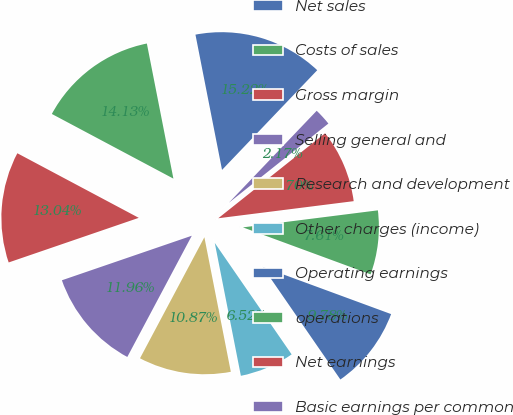Convert chart to OTSL. <chart><loc_0><loc_0><loc_500><loc_500><pie_chart><fcel>Net sales<fcel>Costs of sales<fcel>Gross margin<fcel>Selling general and<fcel>Research and development<fcel>Other charges (income)<fcel>Operating earnings<fcel>operations<fcel>Net earnings<fcel>Basic earnings per common<nl><fcel>15.22%<fcel>14.13%<fcel>13.04%<fcel>11.96%<fcel>10.87%<fcel>6.52%<fcel>9.78%<fcel>7.61%<fcel>8.7%<fcel>2.17%<nl></chart> 